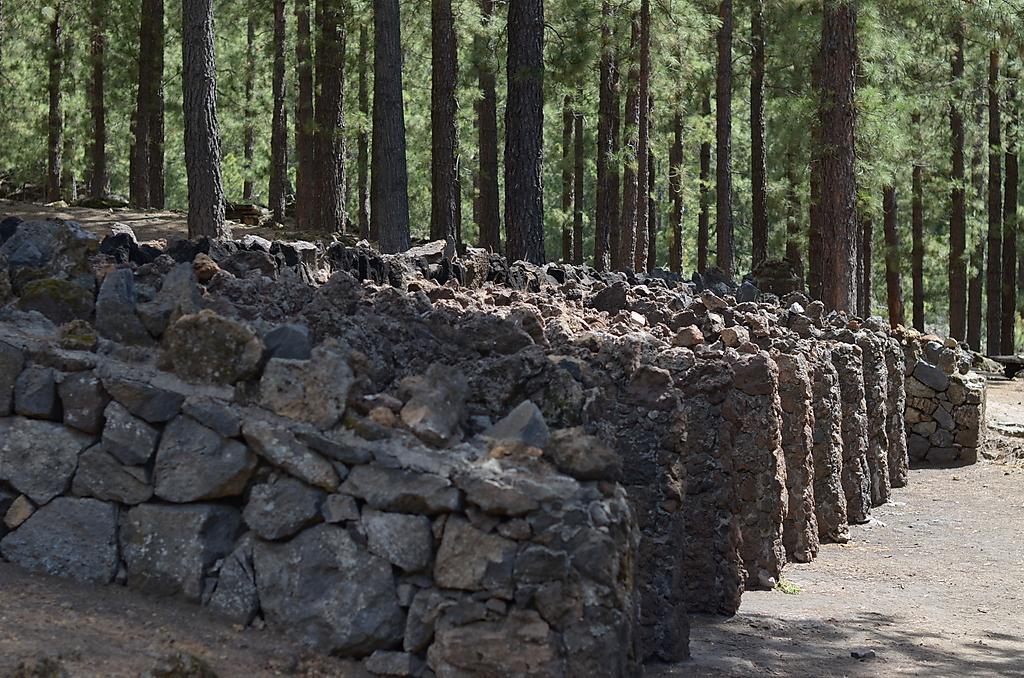Please provide a concise description of this image. In this picture I can see number of stones in front and on the right side I see the path and in the background I see number of trees. 